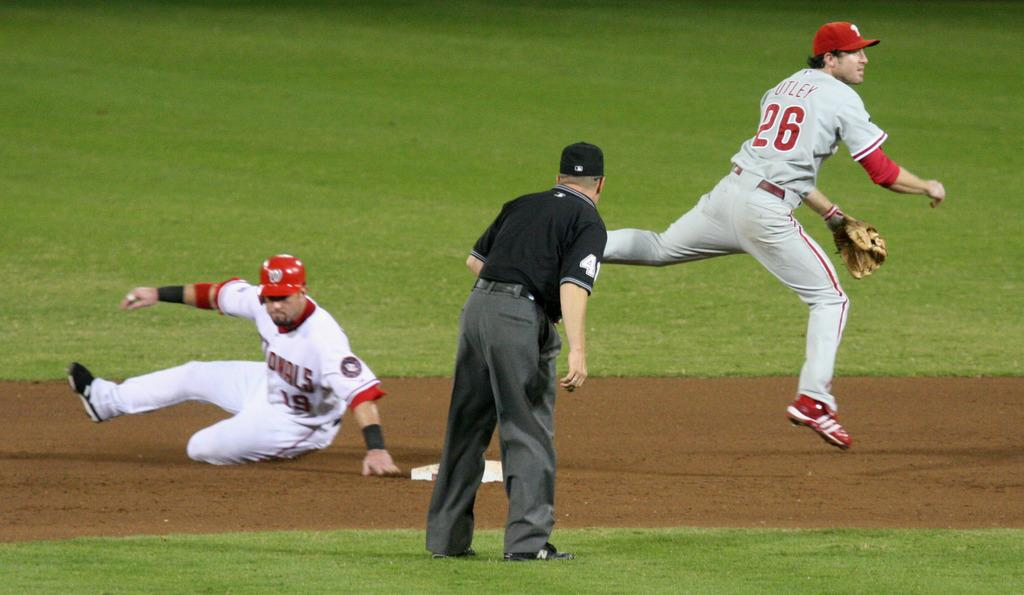<image>
Create a compact narrative representing the image presented. A runner slides to the second base as the second baseman leaps over and throws to the first base. 